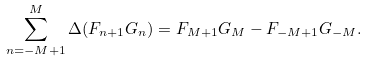Convert formula to latex. <formula><loc_0><loc_0><loc_500><loc_500>\sum _ { n = - M + 1 } ^ { M } \Delta ( F _ { n + 1 } G _ { n } ) = F _ { M + 1 } G _ { M } - F _ { - M + 1 } G _ { - M } .</formula> 